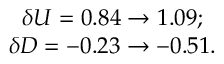<formula> <loc_0><loc_0><loc_500><loc_500>\begin{array} { c l c r } { \delta U = 0 . 8 4 \to 1 . 0 9 ; } \\ { \delta D = - 0 . 2 3 \to - 0 . 5 1 . } \end{array}</formula> 